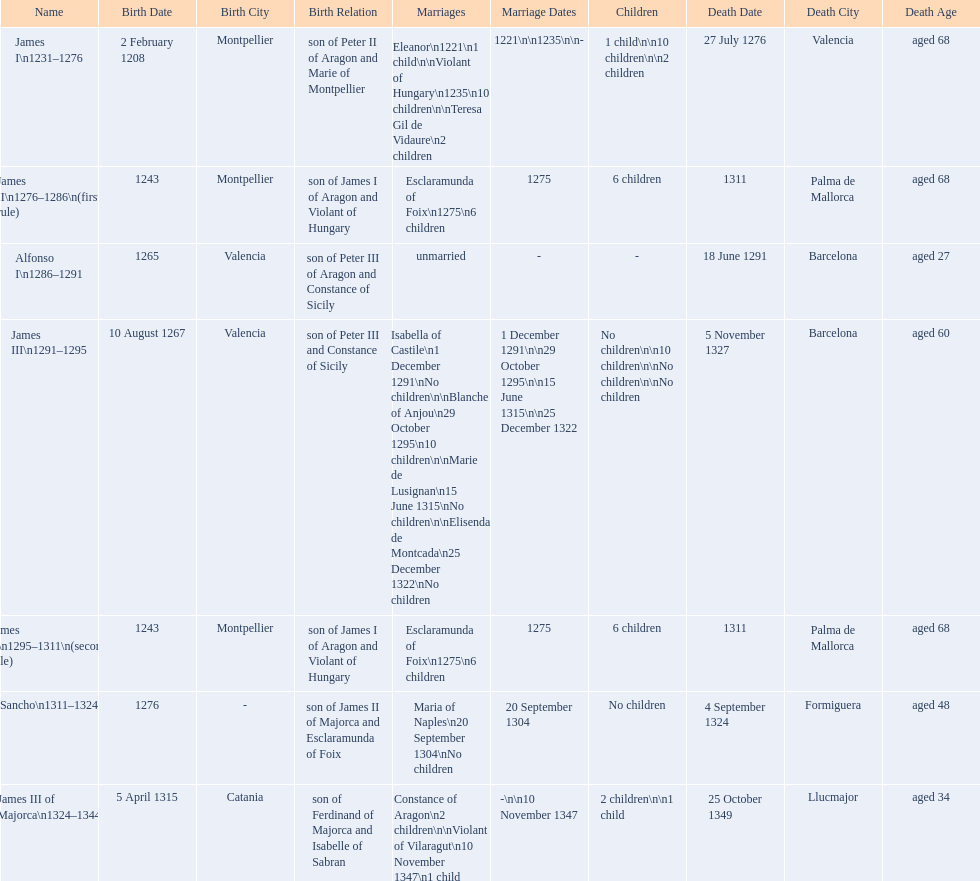James i and james ii both died at what age? 68. 